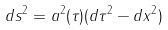Convert formula to latex. <formula><loc_0><loc_0><loc_500><loc_500>d s ^ { 2 } = a ^ { 2 } ( \tau ) ( d \tau ^ { 2 } - d x ^ { 2 } )</formula> 